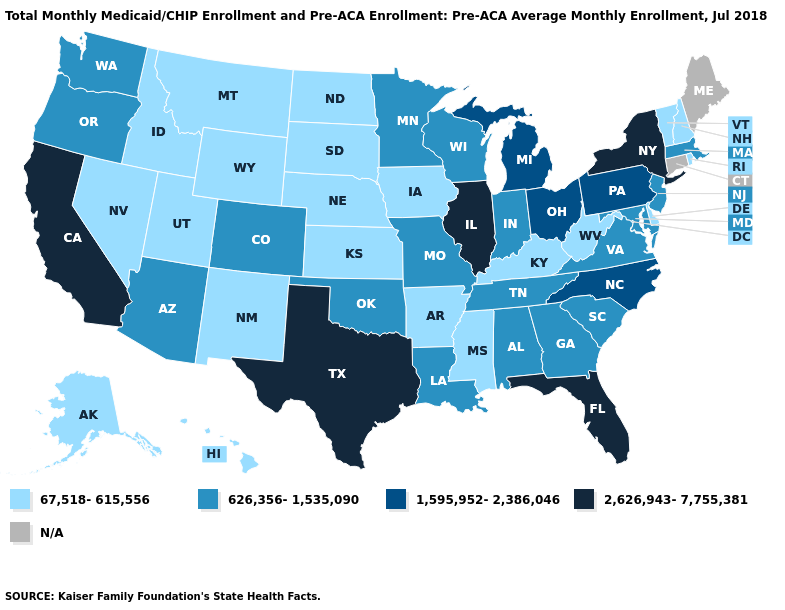Name the states that have a value in the range 626,356-1,535,090?
Concise answer only. Alabama, Arizona, Colorado, Georgia, Indiana, Louisiana, Maryland, Massachusetts, Minnesota, Missouri, New Jersey, Oklahoma, Oregon, South Carolina, Tennessee, Virginia, Washington, Wisconsin. Among the states that border Colorado , which have the lowest value?
Answer briefly. Kansas, Nebraska, New Mexico, Utah, Wyoming. Among the states that border Vermont , which have the lowest value?
Short answer required. New Hampshire. Name the states that have a value in the range 626,356-1,535,090?
Quick response, please. Alabama, Arizona, Colorado, Georgia, Indiana, Louisiana, Maryland, Massachusetts, Minnesota, Missouri, New Jersey, Oklahoma, Oregon, South Carolina, Tennessee, Virginia, Washington, Wisconsin. Which states have the lowest value in the USA?
Be succinct. Alaska, Arkansas, Delaware, Hawaii, Idaho, Iowa, Kansas, Kentucky, Mississippi, Montana, Nebraska, Nevada, New Hampshire, New Mexico, North Dakota, Rhode Island, South Dakota, Utah, Vermont, West Virginia, Wyoming. Does California have the highest value in the West?
Keep it brief. Yes. Among the states that border Alabama , does Mississippi have the lowest value?
Give a very brief answer. Yes. What is the highest value in the USA?
Give a very brief answer. 2,626,943-7,755,381. What is the value of Mississippi?
Be succinct. 67,518-615,556. What is the value of Connecticut?
Short answer required. N/A. Which states have the highest value in the USA?
Concise answer only. California, Florida, Illinois, New York, Texas. Does Delaware have the lowest value in the South?
Give a very brief answer. Yes. What is the lowest value in the South?
Concise answer only. 67,518-615,556. What is the highest value in the West ?
Give a very brief answer. 2,626,943-7,755,381. Name the states that have a value in the range 1,595,952-2,386,046?
Answer briefly. Michigan, North Carolina, Ohio, Pennsylvania. 